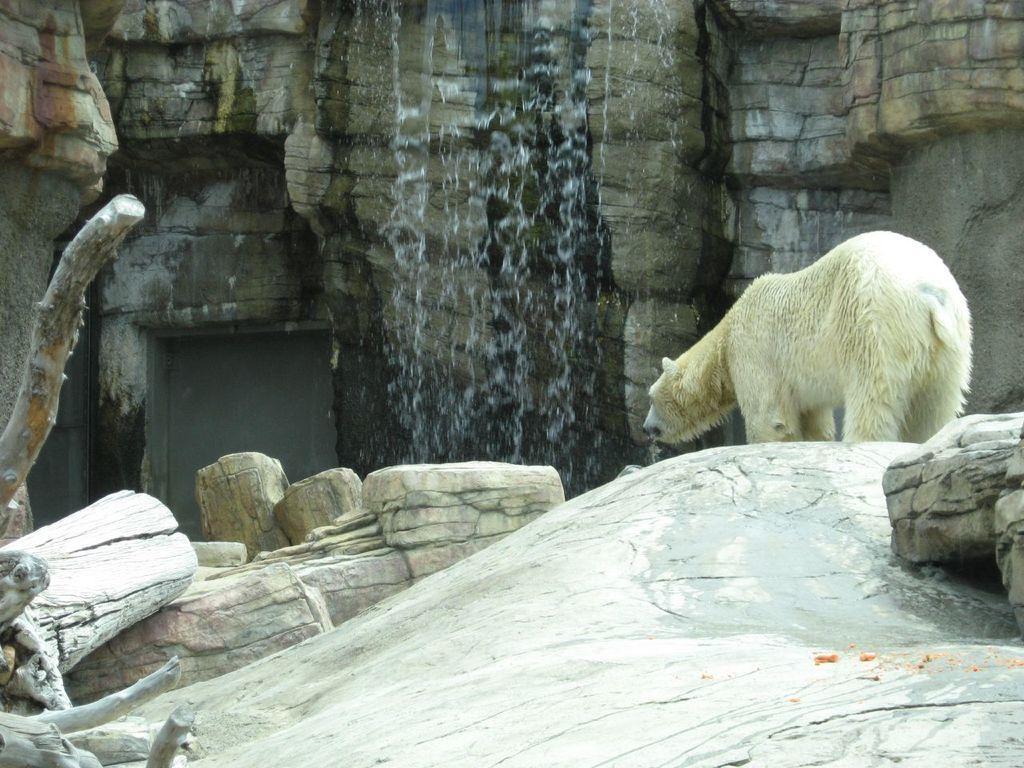Describe this image in one or two sentences. In this picture we can see a polar bear on the right side, on the left side we can see some wood, in the background there is waterfall and a hill. 